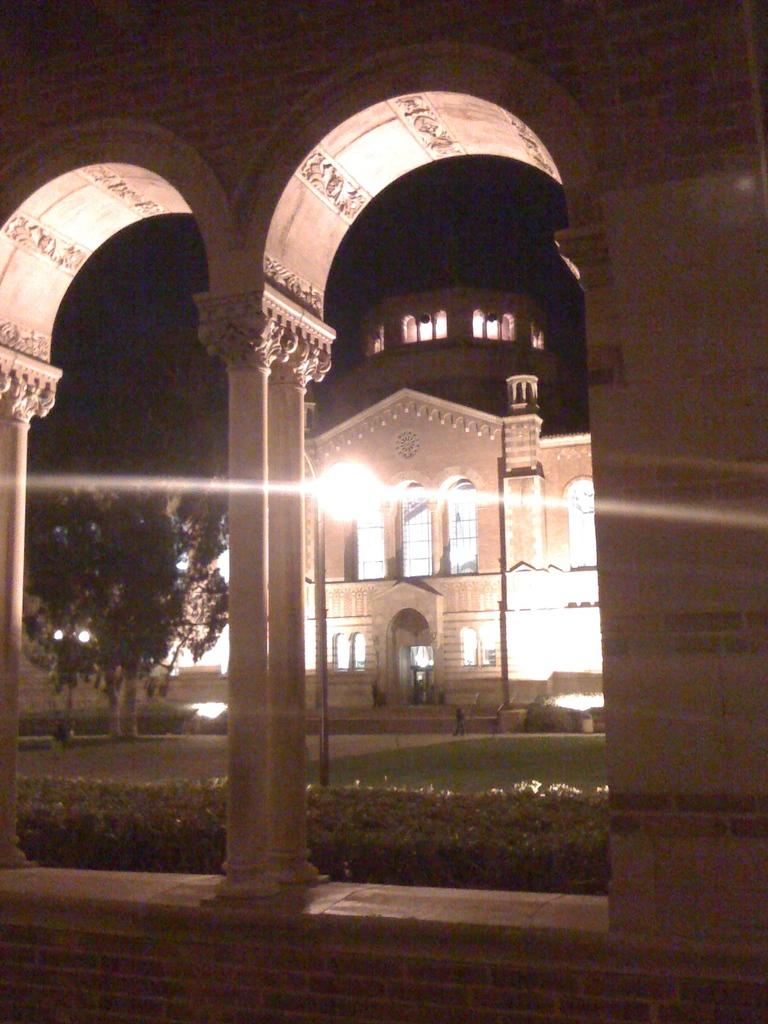What types of living organisms can be seen in the image? Plants and trees are visible in the image. What type of structures are present in the image? Buildings, pillars, and windows are present in the image. What can be seen illuminating the image? Lights are visible in the image. What type of natural vegetation is present in the image? Trees are present in the image. What is the reaction of the plants to the ongoing war in the image? There is no war present in the image, and therefore no reaction of the plants can be observed. What time of day is depicted in the image? The image may have been taken during the night, but the exact time of day cannot be determined from the image alone. 